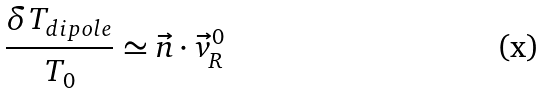Convert formula to latex. <formula><loc_0><loc_0><loc_500><loc_500>\frac { \delta T _ { d i p o l e } } { T _ { 0 } } \simeq \vec { n } \cdot \vec { v } _ { R } ^ { 0 }</formula> 